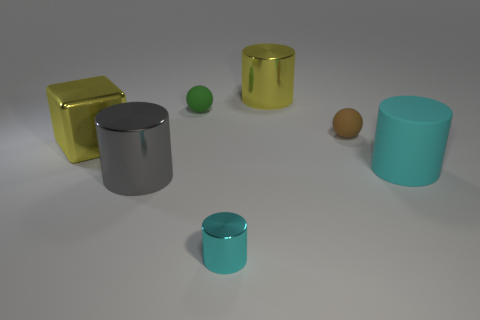Is the shape of the gray metallic thing the same as the metal object that is in front of the gray metal object? yes 